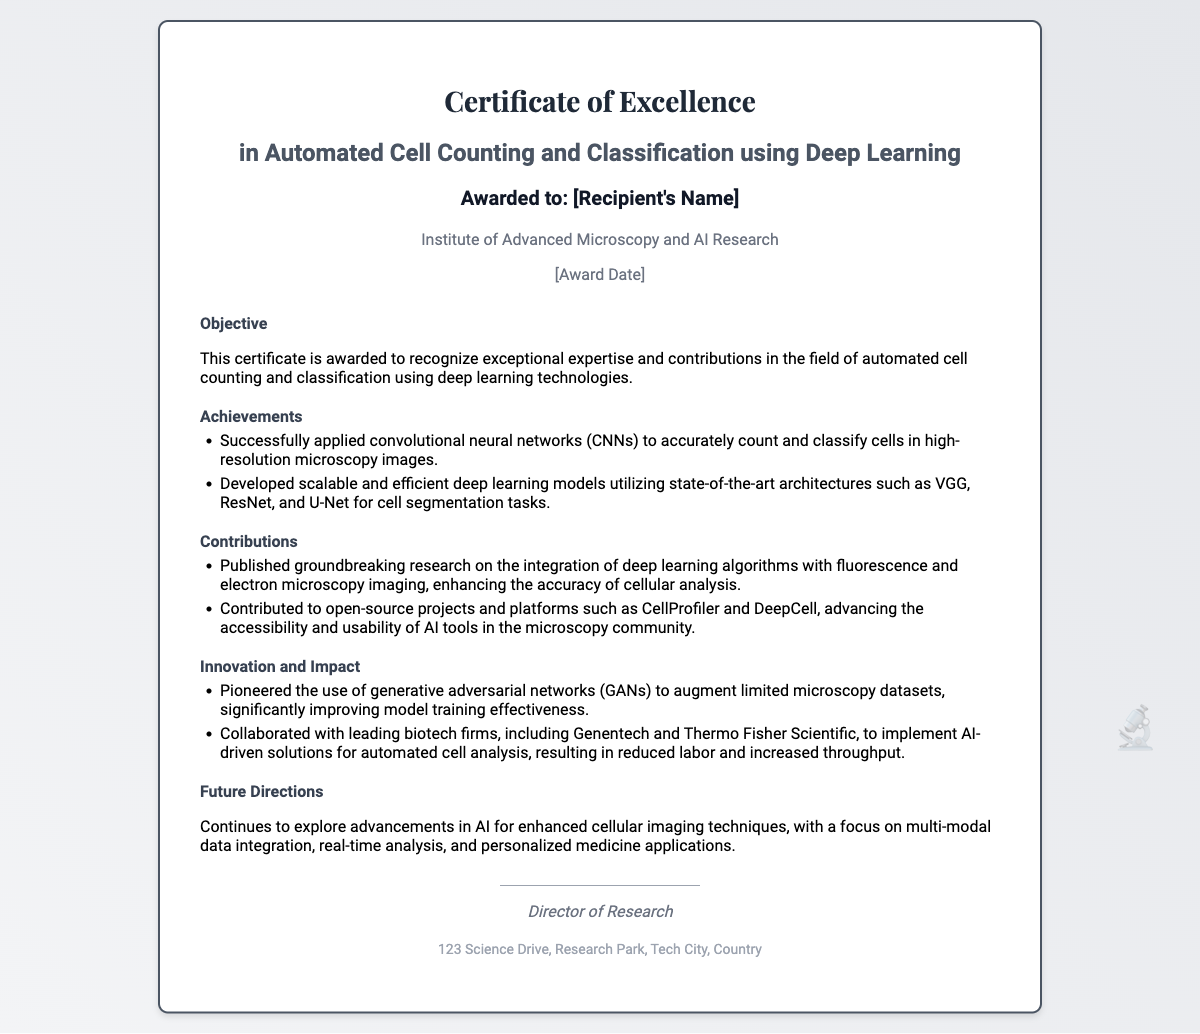What is the title of the certificate? The title of the certificate is prominently displayed at the top of the document, which reads "Certificate of Excellence in Automated Cell Counting and Classification using Deep Learning."
Answer: Certificate of Excellence in Automated Cell Counting and Classification using Deep Learning Who is the recipient of the certificate? The recipient's name is indicated with the placeholder "[Recipient's Name]".
Answer: [Recipient's Name] What is the name of the institution awarding the certificate? The institution is mentioned right below the recipient's name, identifying it as the Institute of Advanced Microscopy and AI Research.
Answer: Institute of Advanced Microscopy and AI Research What are two achievements listed in the document? The achievements section lists specific accomplishments, including "Successfully applied convolutional neural networks (CNNs) to accurately count and classify cells in high-resolution microscopy images" and "Developed scalable and efficient deep learning models utilizing state-of-the-art architectures such as VGG, ResNet, and U-Net for cell segmentation tasks."
Answer: Successfully applied convolutional neural networks (CNNs) to accurately count and classify cells in high-resolution microscopy images; Developed scalable and efficient deep learning models utilizing state-of-the-art architectures such as VGG, ResNet, and U-Net for cell segmentation tasks What is one contribution made by the awardee? The contributions include published research, specifically "Published groundbreaking research on the integration of deep learning algorithms with fluorescence and electron microscopy imaging, enhancing the accuracy of cellular analysis."
Answer: Published groundbreaking research on the integration of deep learning algorithms with fluorescence and electron microscopy imaging, enhancing the accuracy of cellular analysis What is mentioned as a future direction for the awardee's research? The future directions highlight ongoing research focus, stating that it "continues to explore advancements in AI for enhanced cellular imaging techniques."
Answer: Continues to explore advancements in AI for enhanced cellular imaging techniques What role is mentioned at the bottom of the certificate? The role of the person signing the certificate is indicated below the signature line, stating "Director of Research."
Answer: Director of Research What symbol appears in the bottom right corner of the certificate? A seal symbol is located in the bottom right area and is represented as "🔬".
Answer: 🔬 